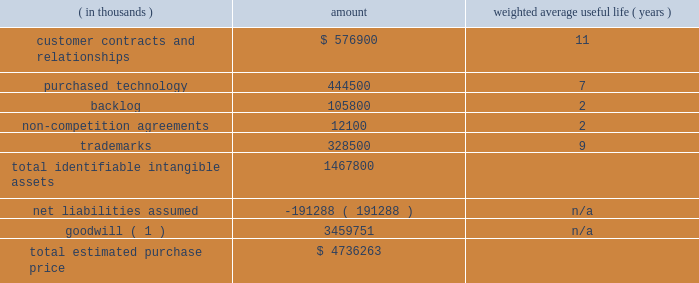Table of contents adobe inc .
Notes to consolidated financial statements ( continued ) the table below represents the preliminary purchase price allocation to the acquired net tangible and intangible assets of marketo based on their estimated fair values as of the acquisition date and the associated estimated useful lives at that date .
The fair values assigned to assets acquired and liabilities assumed are based on management 2019s best estimates and assumptions as of the reporting date and are considered preliminary pending finalization of valuation analyses pertaining to intangible assets acquired , deferred revenue and tax liabilities assumed including the calculation of deferred tax assets and liabilities .
( in thousands ) amount weighted average useful life ( years ) .
_________________________________________ ( 1 ) non-deductible for tax-purposes .
Identifiable intangible assets 2014customer relationships consist of marketo 2019s contractual relationships and customer loyalty related to their enterprise and commercial customers as well as technology partner relationships .
The estimated fair value of the customer contracts and relationships was determined based on projected cash flows attributable to the asset .
Purchased technology acquired primarily consists of marketo 2019s cloud-based engagement marketing software platform .
The estimated fair value of the purchased technology was determined based on the expected future cost savings resulting from ownership of the asset .
Backlog relates to subscription contracts and professional services .
Non-compete agreements include agreements with key marketo employees that preclude them from competing against marketo for a period of two years from the acquisition date .
Trademarks include the marketo trade name , which is well known in the marketing ecosystem .
We amortize the fair value of these intangible assets on a straight-line basis over their respective estimated useful lives .
Goodwill 2014approximately $ 3.46 billion has been allocated to goodwill , and has been allocated in full to the digital experience reportable segment .
Goodwill represents the excess of the purchase price over the fair value of the underlying acquired net tangible and intangible assets .
The factors that contributed to the recognition of goodwill included securing buyer-specific synergies that increase revenue and profits and are not otherwise available to a marketplace participant , acquiring a talented workforce and cost savings opportunities .
Net liabilities assumed 2014marketo 2019s tangible assets and liabilities as of october 31 , 2018 were reviewed and adjusted to their fair value as necessary .
The net liabilities assumed included , among other items , $ 100.1 million in accrued expenses , $ 74.8 million in deferred revenue and $ 182.6 million in deferred tax liabilities , which were partially offset by $ 54.9 million in cash and cash equivalents and $ 72.4 million in trade receivables acquired .
Deferred revenue 2014included in net liabilities assumed is marketo 2019s deferred revenue which represents advance payments from customers related to subscription contracts and professional services .
We estimated our obligation related to the deferred revenue using the cost build-up approach .
The cost build-up approach determines fair value by estimating the direct and indirect costs related to supporting the obligation plus an assumed operating margin .
The sum of the costs and assumed operating profit approximates , in theory , the amount that marketo would be required to pay a third party to assume the obligation .
The estimated costs to fulfill the obligation were based on the near-term projected cost structure for subscription and professional services .
As a result , we recorded an adjustment to reduce marketo 2019s carrying value of deferred revenue to $ 74.8 million , which represents our estimate of the fair value of the contractual obligations assumed based on a preliminary valuation. .
What is the total in millions for goodwill for purchased technology and backlog? 
Computations: (444500 + 105800)
Answer: 550300.0. 